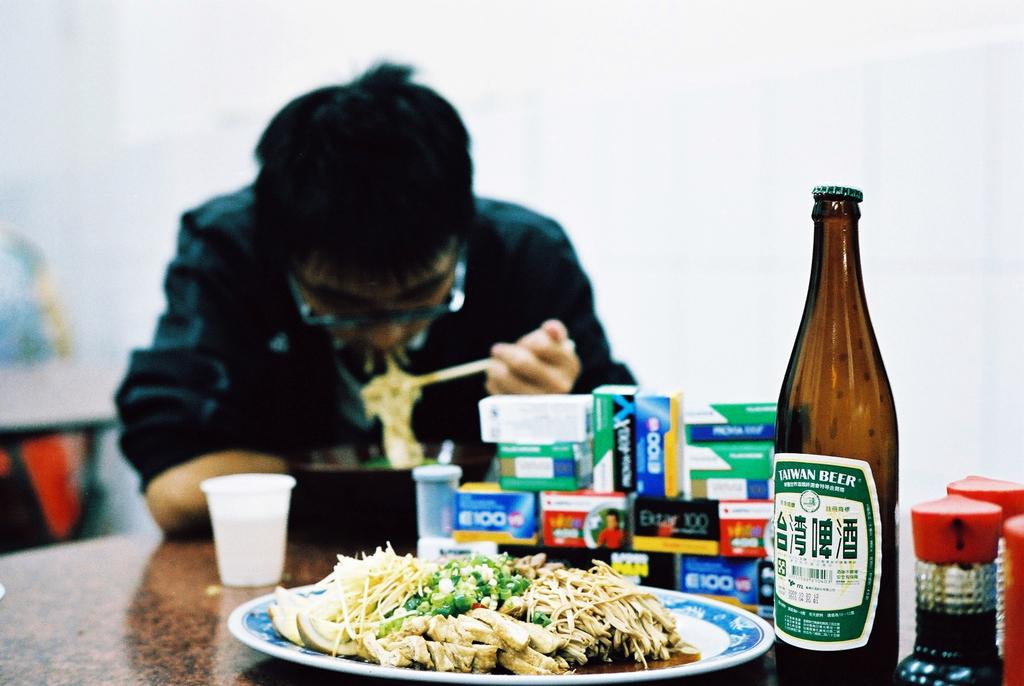<image>
Relay a brief, clear account of the picture shown. A man eats noodles with chopsticks at a table with a stack of small boxes and a bottle of Taiwan Beer. 